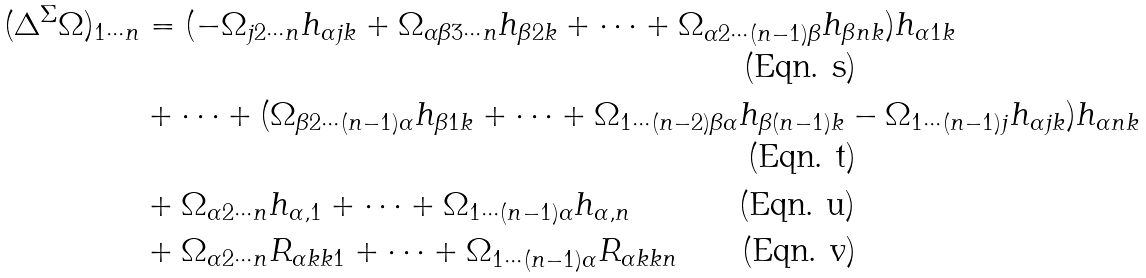Convert formula to latex. <formula><loc_0><loc_0><loc_500><loc_500>( \Delta ^ { \Sigma } \Omega ) _ { 1 \cdots n } & = ( - \Omega _ { j 2 \cdots n } h _ { \alpha j k } + \Omega _ { \alpha \beta 3 \cdots n } h _ { \beta 2 k } + \cdots + \Omega _ { \alpha 2 \cdots ( n - 1 ) \beta } h _ { \beta n k } ) h _ { \alpha 1 k } \\ & + \cdots + ( \Omega _ { \beta 2 \cdots ( n - 1 ) \alpha } h _ { \beta 1 k } + \cdots + \Omega _ { 1 \cdots ( n - 2 ) \beta \alpha } h _ { \beta ( n - 1 ) k } - \Omega _ { 1 \cdots ( n - 1 ) j } h _ { \alpha j k } ) h _ { \alpha n k } \\ & + \Omega _ { \alpha 2 \cdots n } h _ { \alpha , 1 } + \cdots + \Omega _ { 1 \cdots ( n - 1 ) \alpha } h _ { \alpha , n } \\ & + \Omega _ { \alpha 2 \cdots n } R _ { \alpha k k 1 } + \cdots + \Omega _ { 1 \cdots ( n - 1 ) \alpha } R _ { \alpha k k n }</formula> 